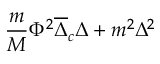Convert formula to latex. <formula><loc_0><loc_0><loc_500><loc_500>{ \frac { m } { M } } \Phi ^ { 2 } \overline { \Delta } _ { c } \Delta + m ^ { 2 } \Delta ^ { 2 }</formula> 